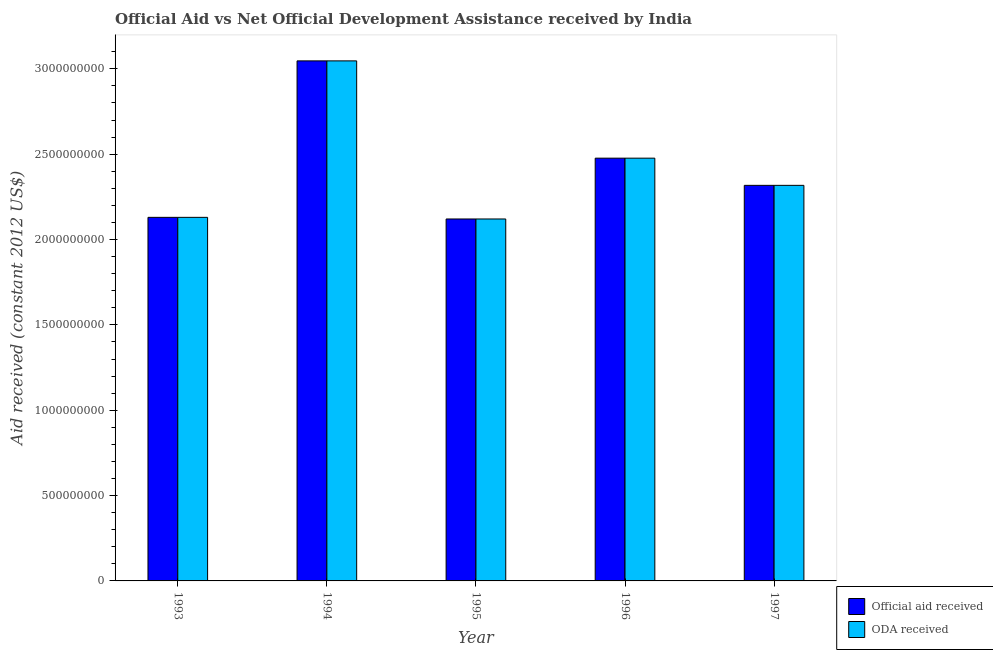How many groups of bars are there?
Provide a short and direct response. 5. How many bars are there on the 2nd tick from the left?
Keep it short and to the point. 2. How many bars are there on the 3rd tick from the right?
Provide a short and direct response. 2. What is the oda received in 1995?
Offer a very short reply. 2.12e+09. Across all years, what is the maximum official aid received?
Keep it short and to the point. 3.05e+09. Across all years, what is the minimum oda received?
Your answer should be compact. 2.12e+09. In which year was the official aid received minimum?
Your response must be concise. 1995. What is the total oda received in the graph?
Make the answer very short. 1.21e+1. What is the difference between the oda received in 1995 and that in 1997?
Keep it short and to the point. -1.97e+08. What is the difference between the official aid received in 1993 and the oda received in 1995?
Provide a short and direct response. 9.53e+06. What is the average oda received per year?
Your response must be concise. 2.42e+09. In the year 1994, what is the difference between the oda received and official aid received?
Provide a short and direct response. 0. In how many years, is the official aid received greater than 2100000000 US$?
Your answer should be compact. 5. What is the ratio of the oda received in 1995 to that in 1996?
Provide a succinct answer. 0.86. Is the oda received in 1995 less than that in 1997?
Provide a short and direct response. Yes. Is the difference between the oda received in 1993 and 1994 greater than the difference between the official aid received in 1993 and 1994?
Ensure brevity in your answer.  No. What is the difference between the highest and the second highest oda received?
Your response must be concise. 5.70e+08. What is the difference between the highest and the lowest oda received?
Your answer should be very brief. 9.26e+08. In how many years, is the official aid received greater than the average official aid received taken over all years?
Make the answer very short. 2. Is the sum of the oda received in 1994 and 1995 greater than the maximum official aid received across all years?
Make the answer very short. Yes. What does the 1st bar from the left in 1997 represents?
Your answer should be compact. Official aid received. What does the 1st bar from the right in 1993 represents?
Your response must be concise. ODA received. How many years are there in the graph?
Offer a very short reply. 5. Are the values on the major ticks of Y-axis written in scientific E-notation?
Give a very brief answer. No. Where does the legend appear in the graph?
Give a very brief answer. Bottom right. How many legend labels are there?
Your answer should be very brief. 2. How are the legend labels stacked?
Provide a short and direct response. Vertical. What is the title of the graph?
Give a very brief answer. Official Aid vs Net Official Development Assistance received by India . Does "Malaria" appear as one of the legend labels in the graph?
Offer a very short reply. No. What is the label or title of the Y-axis?
Keep it short and to the point. Aid received (constant 2012 US$). What is the Aid received (constant 2012 US$) in Official aid received in 1993?
Provide a succinct answer. 2.13e+09. What is the Aid received (constant 2012 US$) of ODA received in 1993?
Offer a very short reply. 2.13e+09. What is the Aid received (constant 2012 US$) in Official aid received in 1994?
Keep it short and to the point. 3.05e+09. What is the Aid received (constant 2012 US$) of ODA received in 1994?
Your response must be concise. 3.05e+09. What is the Aid received (constant 2012 US$) of Official aid received in 1995?
Your answer should be very brief. 2.12e+09. What is the Aid received (constant 2012 US$) of ODA received in 1995?
Your answer should be very brief. 2.12e+09. What is the Aid received (constant 2012 US$) in Official aid received in 1996?
Ensure brevity in your answer.  2.48e+09. What is the Aid received (constant 2012 US$) in ODA received in 1996?
Keep it short and to the point. 2.48e+09. What is the Aid received (constant 2012 US$) in Official aid received in 1997?
Your answer should be very brief. 2.32e+09. What is the Aid received (constant 2012 US$) in ODA received in 1997?
Keep it short and to the point. 2.32e+09. Across all years, what is the maximum Aid received (constant 2012 US$) in Official aid received?
Provide a short and direct response. 3.05e+09. Across all years, what is the maximum Aid received (constant 2012 US$) of ODA received?
Your answer should be compact. 3.05e+09. Across all years, what is the minimum Aid received (constant 2012 US$) of Official aid received?
Ensure brevity in your answer.  2.12e+09. Across all years, what is the minimum Aid received (constant 2012 US$) in ODA received?
Offer a very short reply. 2.12e+09. What is the total Aid received (constant 2012 US$) of Official aid received in the graph?
Your answer should be compact. 1.21e+1. What is the total Aid received (constant 2012 US$) in ODA received in the graph?
Your answer should be compact. 1.21e+1. What is the difference between the Aid received (constant 2012 US$) in Official aid received in 1993 and that in 1994?
Offer a very short reply. -9.17e+08. What is the difference between the Aid received (constant 2012 US$) in ODA received in 1993 and that in 1994?
Your response must be concise. -9.17e+08. What is the difference between the Aid received (constant 2012 US$) in Official aid received in 1993 and that in 1995?
Offer a very short reply. 9.53e+06. What is the difference between the Aid received (constant 2012 US$) of ODA received in 1993 and that in 1995?
Provide a succinct answer. 9.53e+06. What is the difference between the Aid received (constant 2012 US$) in Official aid received in 1993 and that in 1996?
Offer a terse response. -3.47e+08. What is the difference between the Aid received (constant 2012 US$) in ODA received in 1993 and that in 1996?
Offer a very short reply. -3.47e+08. What is the difference between the Aid received (constant 2012 US$) in Official aid received in 1993 and that in 1997?
Offer a very short reply. -1.87e+08. What is the difference between the Aid received (constant 2012 US$) of ODA received in 1993 and that in 1997?
Your response must be concise. -1.87e+08. What is the difference between the Aid received (constant 2012 US$) of Official aid received in 1994 and that in 1995?
Provide a succinct answer. 9.26e+08. What is the difference between the Aid received (constant 2012 US$) of ODA received in 1994 and that in 1995?
Keep it short and to the point. 9.26e+08. What is the difference between the Aid received (constant 2012 US$) of Official aid received in 1994 and that in 1996?
Provide a succinct answer. 5.70e+08. What is the difference between the Aid received (constant 2012 US$) of ODA received in 1994 and that in 1996?
Give a very brief answer. 5.70e+08. What is the difference between the Aid received (constant 2012 US$) in Official aid received in 1994 and that in 1997?
Give a very brief answer. 7.29e+08. What is the difference between the Aid received (constant 2012 US$) in ODA received in 1994 and that in 1997?
Provide a short and direct response. 7.29e+08. What is the difference between the Aid received (constant 2012 US$) in Official aid received in 1995 and that in 1996?
Keep it short and to the point. -3.56e+08. What is the difference between the Aid received (constant 2012 US$) of ODA received in 1995 and that in 1996?
Offer a very short reply. -3.56e+08. What is the difference between the Aid received (constant 2012 US$) of Official aid received in 1995 and that in 1997?
Keep it short and to the point. -1.97e+08. What is the difference between the Aid received (constant 2012 US$) of ODA received in 1995 and that in 1997?
Ensure brevity in your answer.  -1.97e+08. What is the difference between the Aid received (constant 2012 US$) of Official aid received in 1996 and that in 1997?
Provide a succinct answer. 1.59e+08. What is the difference between the Aid received (constant 2012 US$) of ODA received in 1996 and that in 1997?
Make the answer very short. 1.59e+08. What is the difference between the Aid received (constant 2012 US$) in Official aid received in 1993 and the Aid received (constant 2012 US$) in ODA received in 1994?
Provide a succinct answer. -9.17e+08. What is the difference between the Aid received (constant 2012 US$) of Official aid received in 1993 and the Aid received (constant 2012 US$) of ODA received in 1995?
Provide a succinct answer. 9.53e+06. What is the difference between the Aid received (constant 2012 US$) in Official aid received in 1993 and the Aid received (constant 2012 US$) in ODA received in 1996?
Your answer should be compact. -3.47e+08. What is the difference between the Aid received (constant 2012 US$) in Official aid received in 1993 and the Aid received (constant 2012 US$) in ODA received in 1997?
Offer a terse response. -1.87e+08. What is the difference between the Aid received (constant 2012 US$) in Official aid received in 1994 and the Aid received (constant 2012 US$) in ODA received in 1995?
Your answer should be very brief. 9.26e+08. What is the difference between the Aid received (constant 2012 US$) of Official aid received in 1994 and the Aid received (constant 2012 US$) of ODA received in 1996?
Ensure brevity in your answer.  5.70e+08. What is the difference between the Aid received (constant 2012 US$) in Official aid received in 1994 and the Aid received (constant 2012 US$) in ODA received in 1997?
Keep it short and to the point. 7.29e+08. What is the difference between the Aid received (constant 2012 US$) of Official aid received in 1995 and the Aid received (constant 2012 US$) of ODA received in 1996?
Ensure brevity in your answer.  -3.56e+08. What is the difference between the Aid received (constant 2012 US$) in Official aid received in 1995 and the Aid received (constant 2012 US$) in ODA received in 1997?
Offer a terse response. -1.97e+08. What is the difference between the Aid received (constant 2012 US$) of Official aid received in 1996 and the Aid received (constant 2012 US$) of ODA received in 1997?
Offer a terse response. 1.59e+08. What is the average Aid received (constant 2012 US$) of Official aid received per year?
Offer a terse response. 2.42e+09. What is the average Aid received (constant 2012 US$) of ODA received per year?
Provide a succinct answer. 2.42e+09. In the year 1997, what is the difference between the Aid received (constant 2012 US$) of Official aid received and Aid received (constant 2012 US$) of ODA received?
Provide a short and direct response. 0. What is the ratio of the Aid received (constant 2012 US$) of Official aid received in 1993 to that in 1994?
Ensure brevity in your answer.  0.7. What is the ratio of the Aid received (constant 2012 US$) in ODA received in 1993 to that in 1994?
Your response must be concise. 0.7. What is the ratio of the Aid received (constant 2012 US$) in Official aid received in 1993 to that in 1996?
Your answer should be compact. 0.86. What is the ratio of the Aid received (constant 2012 US$) of ODA received in 1993 to that in 1996?
Provide a succinct answer. 0.86. What is the ratio of the Aid received (constant 2012 US$) of Official aid received in 1993 to that in 1997?
Your response must be concise. 0.92. What is the ratio of the Aid received (constant 2012 US$) of ODA received in 1993 to that in 1997?
Make the answer very short. 0.92. What is the ratio of the Aid received (constant 2012 US$) in Official aid received in 1994 to that in 1995?
Offer a terse response. 1.44. What is the ratio of the Aid received (constant 2012 US$) in ODA received in 1994 to that in 1995?
Your answer should be very brief. 1.44. What is the ratio of the Aid received (constant 2012 US$) in Official aid received in 1994 to that in 1996?
Provide a short and direct response. 1.23. What is the ratio of the Aid received (constant 2012 US$) of ODA received in 1994 to that in 1996?
Your answer should be very brief. 1.23. What is the ratio of the Aid received (constant 2012 US$) in Official aid received in 1994 to that in 1997?
Your response must be concise. 1.31. What is the ratio of the Aid received (constant 2012 US$) of ODA received in 1994 to that in 1997?
Make the answer very short. 1.31. What is the ratio of the Aid received (constant 2012 US$) of Official aid received in 1995 to that in 1996?
Ensure brevity in your answer.  0.86. What is the ratio of the Aid received (constant 2012 US$) in ODA received in 1995 to that in 1996?
Provide a succinct answer. 0.86. What is the ratio of the Aid received (constant 2012 US$) of Official aid received in 1995 to that in 1997?
Your response must be concise. 0.92. What is the ratio of the Aid received (constant 2012 US$) of ODA received in 1995 to that in 1997?
Give a very brief answer. 0.92. What is the ratio of the Aid received (constant 2012 US$) in Official aid received in 1996 to that in 1997?
Your answer should be compact. 1.07. What is the ratio of the Aid received (constant 2012 US$) of ODA received in 1996 to that in 1997?
Your response must be concise. 1.07. What is the difference between the highest and the second highest Aid received (constant 2012 US$) in Official aid received?
Provide a short and direct response. 5.70e+08. What is the difference between the highest and the second highest Aid received (constant 2012 US$) of ODA received?
Your response must be concise. 5.70e+08. What is the difference between the highest and the lowest Aid received (constant 2012 US$) of Official aid received?
Offer a very short reply. 9.26e+08. What is the difference between the highest and the lowest Aid received (constant 2012 US$) of ODA received?
Provide a succinct answer. 9.26e+08. 